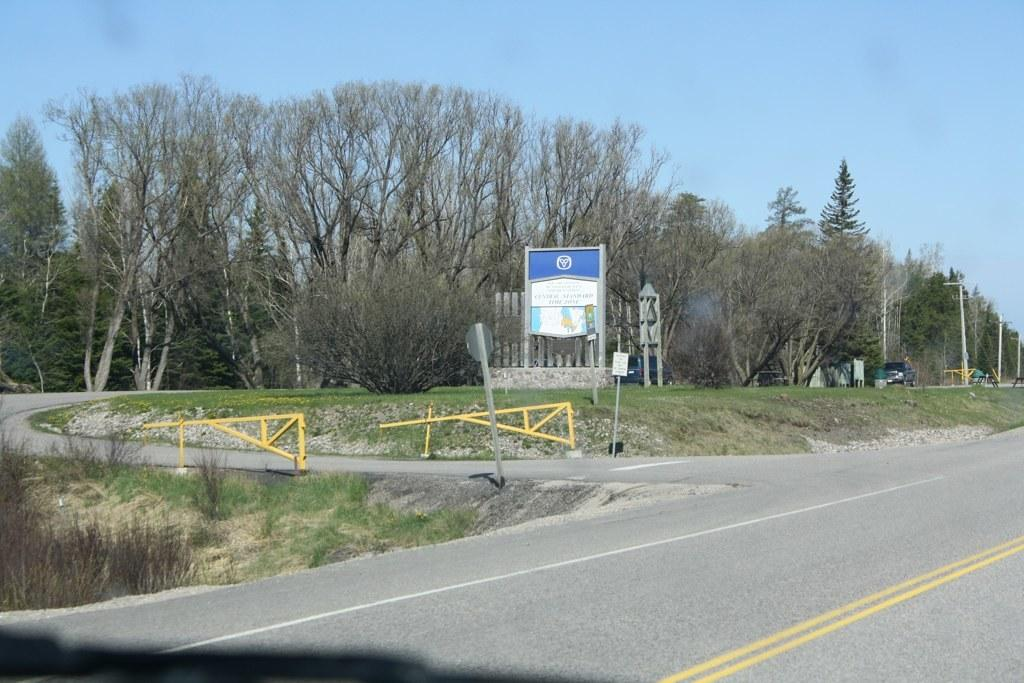What is the main feature of the image? There is a road in the image. What can be seen in the background of the image? There are trees, electric poles, vehicles, boards, and the sky visible in the background of the image. How many children are playing with the parcel on the road in the image? There are no children or parcels present in the image. What type of pump is visible in the background of the image? There is no pump visible in the background of the image. 